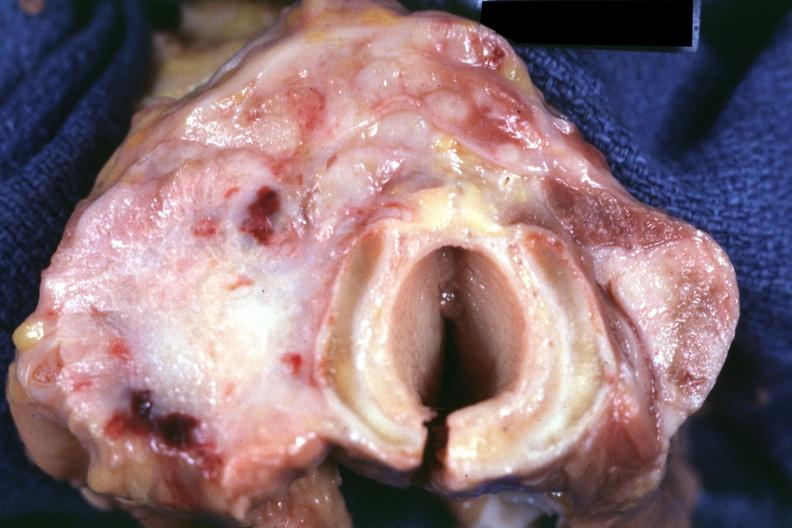what is carcinoma had?
Answer the question using a single word or phrase. Metastases to lungs, pleura, liver and regional nodes 